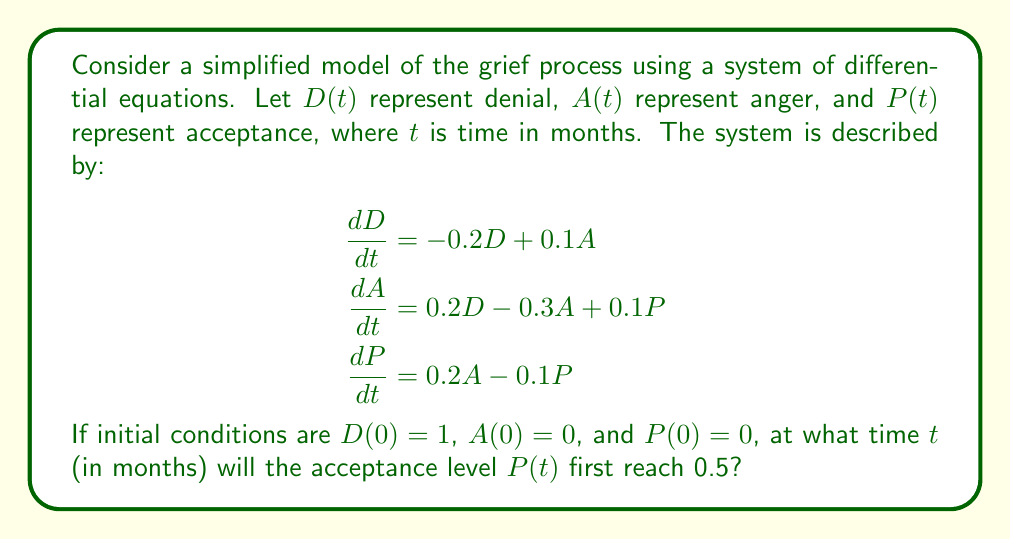Show me your answer to this math problem. To solve this problem, we need to use numerical methods to approximate the solution of the system of differential equations. We'll use the Euler method with a small step size to estimate the values of $D(t)$, $A(t)$, and $P(t)$ over time.

1. Initialize variables:
   $t = 0$
   $D = 1$
   $A = 0$
   $P = 0$
   $\Delta t = 0.01$ (step size in months)

2. Implement the Euler method:
   While $P < 0.5$, repeat:
   $$\begin{aligned}
   D_{new} &= D + (-0.2D + 0.1A) \cdot \Delta t \\
   A_{new} &= A + (0.2D - 0.3A + 0.1P) \cdot \Delta t \\
   P_{new} &= P + (0.2A - 0.1P) \cdot \Delta t \\
   t &= t + \Delta t \\
   D &= D_{new} \\
   A &= A_{new} \\
   P &= P_{new}
   \end{aligned}$$

3. Continue the iteration until $P \geq 0.5$.

4. The final value of $t$ will be the approximate time when acceptance level reaches 0.5.

Implementing this algorithm (which can be done using a computer program or spreadsheet), we find that $P(t)$ first reaches 0.5 at approximately $t = 7.23$ months.

This result illustrates that the journey through grief is a gradual process, and it may take several months before a significant level of acceptance is reached. The model also shows the interplay between different stages of grief, highlighting the importance of patience and self-care during the healing process.
Answer: The acceptance level $P(t)$ first reaches 0.5 at approximately 7.23 months. 